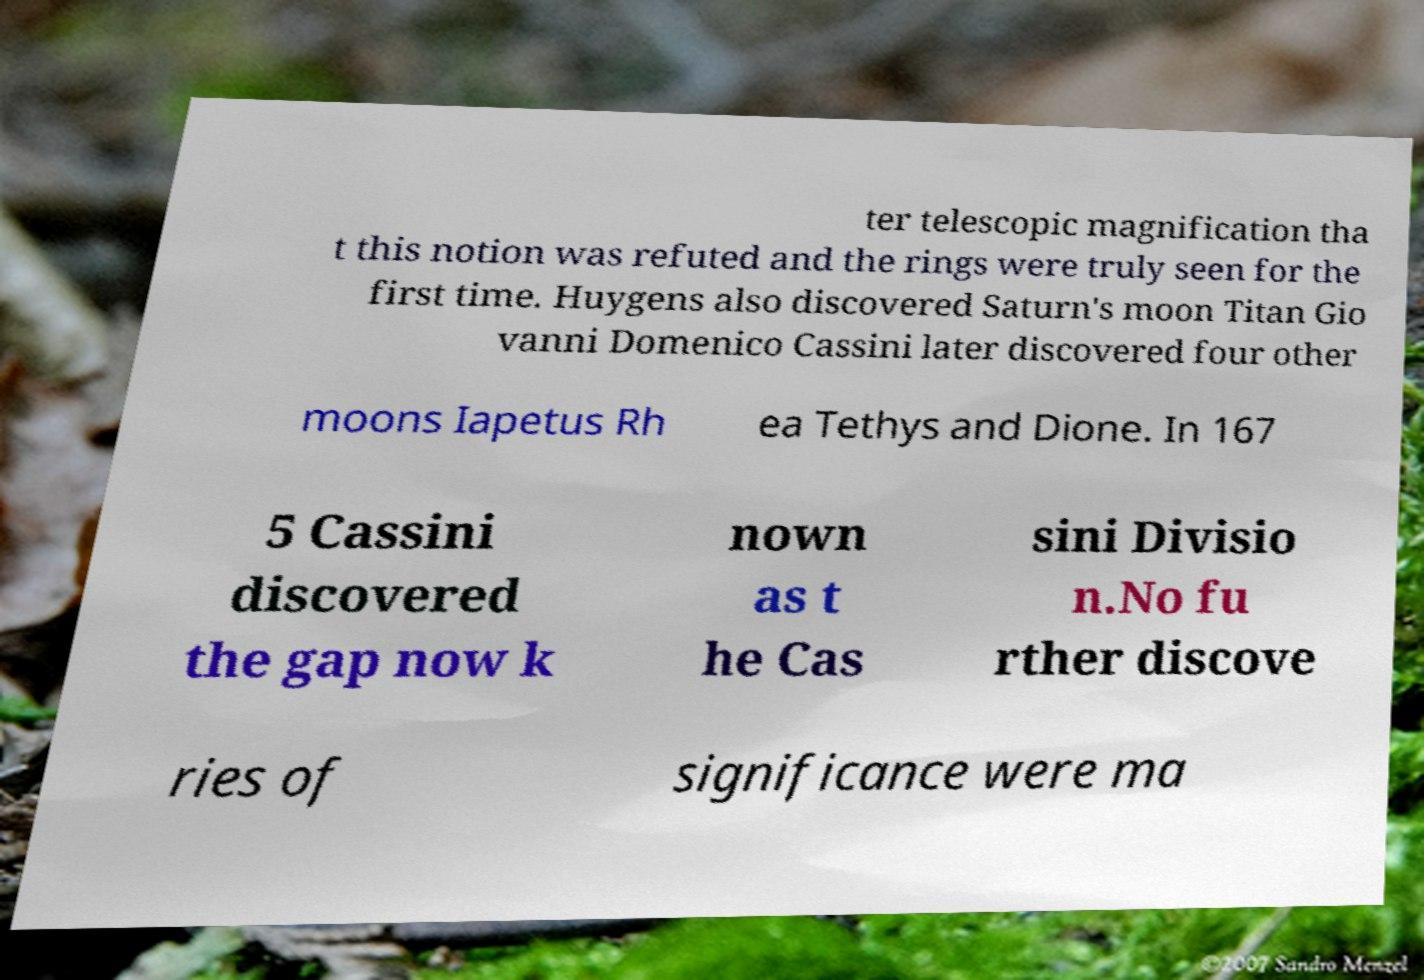I need the written content from this picture converted into text. Can you do that? ter telescopic magnification tha t this notion was refuted and the rings were truly seen for the first time. Huygens also discovered Saturn's moon Titan Gio vanni Domenico Cassini later discovered four other moons Iapetus Rh ea Tethys and Dione. In 167 5 Cassini discovered the gap now k nown as t he Cas sini Divisio n.No fu rther discove ries of significance were ma 